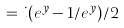Convert formula to latex. <formula><loc_0><loc_0><loc_500><loc_500>= i ( e ^ { y } - 1 / e ^ { y } ) / 2</formula> 